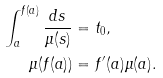Convert formula to latex. <formula><loc_0><loc_0><loc_500><loc_500>\int _ { a } ^ { f ( a ) } \frac { d s } { \mu ( s ) } & = t _ { 0 } , \\ \mu ( f ( a ) ) & = f ^ { \prime } ( a ) \mu ( a ) .</formula> 